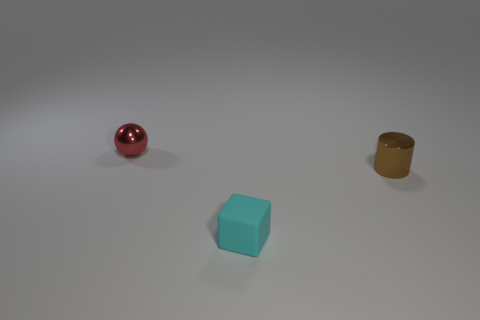The cyan thing that is the same size as the brown shiny thing is what shape?
Your answer should be very brief. Cube. Are there an equal number of small red shiny things right of the tiny shiny cylinder and cyan blocks that are on the left side of the small red metallic ball?
Offer a very short reply. Yes. Are there any other things that are the same shape as the cyan rubber object?
Your answer should be very brief. No. Are the tiny thing right of the tiny matte thing and the small cyan block made of the same material?
Provide a short and direct response. No. What is the material of the red ball that is the same size as the brown thing?
Your response must be concise. Metal. What number of other objects are the same material as the small cylinder?
Offer a terse response. 1. There is a rubber thing; is its size the same as the shiny object that is on the right side of the ball?
Offer a terse response. Yes. Are there fewer small brown cylinders in front of the small brown object than tiny cylinders that are right of the tiny cyan matte cube?
Your response must be concise. Yes. There is a metal object behind the small cylinder; what size is it?
Offer a terse response. Small. Do the rubber block and the metallic ball have the same size?
Make the answer very short. Yes. 